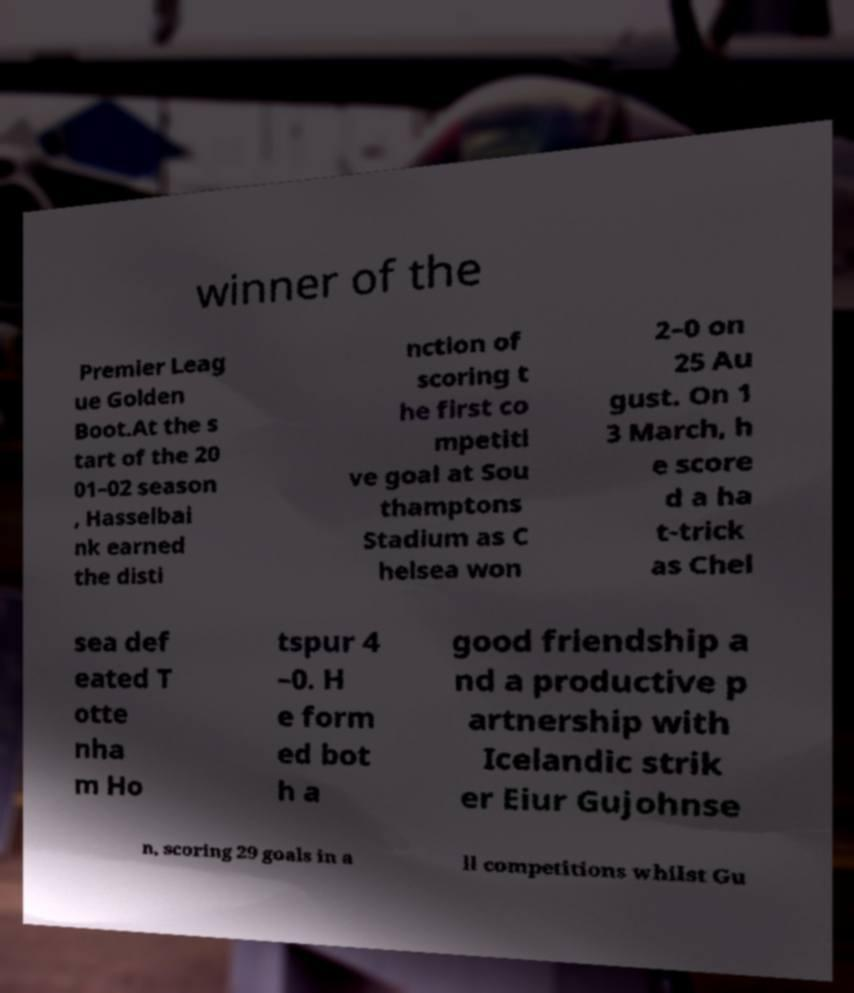Could you extract and type out the text from this image? winner of the Premier Leag ue Golden Boot.At the s tart of the 20 01–02 season , Hasselbai nk earned the disti nction of scoring t he first co mpetiti ve goal at Sou thamptons Stadium as C helsea won 2–0 on 25 Au gust. On 1 3 March, h e score d a ha t-trick as Chel sea def eated T otte nha m Ho tspur 4 –0. H e form ed bot h a good friendship a nd a productive p artnership with Icelandic strik er Eiur Gujohnse n, scoring 29 goals in a ll competitions whilst Gu 